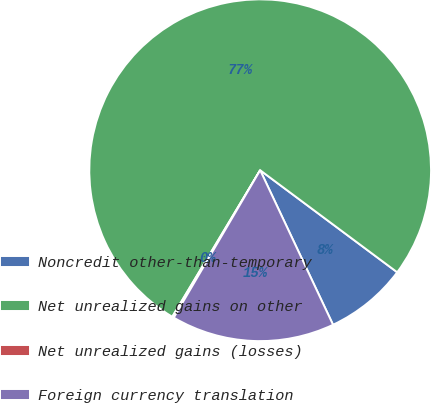Convert chart to OTSL. <chart><loc_0><loc_0><loc_500><loc_500><pie_chart><fcel>Noncredit other-than-temporary<fcel>Net unrealized gains on other<fcel>Net unrealized gains (losses)<fcel>Foreign currency translation<nl><fcel>7.8%<fcel>76.59%<fcel>0.16%<fcel>15.45%<nl></chart> 